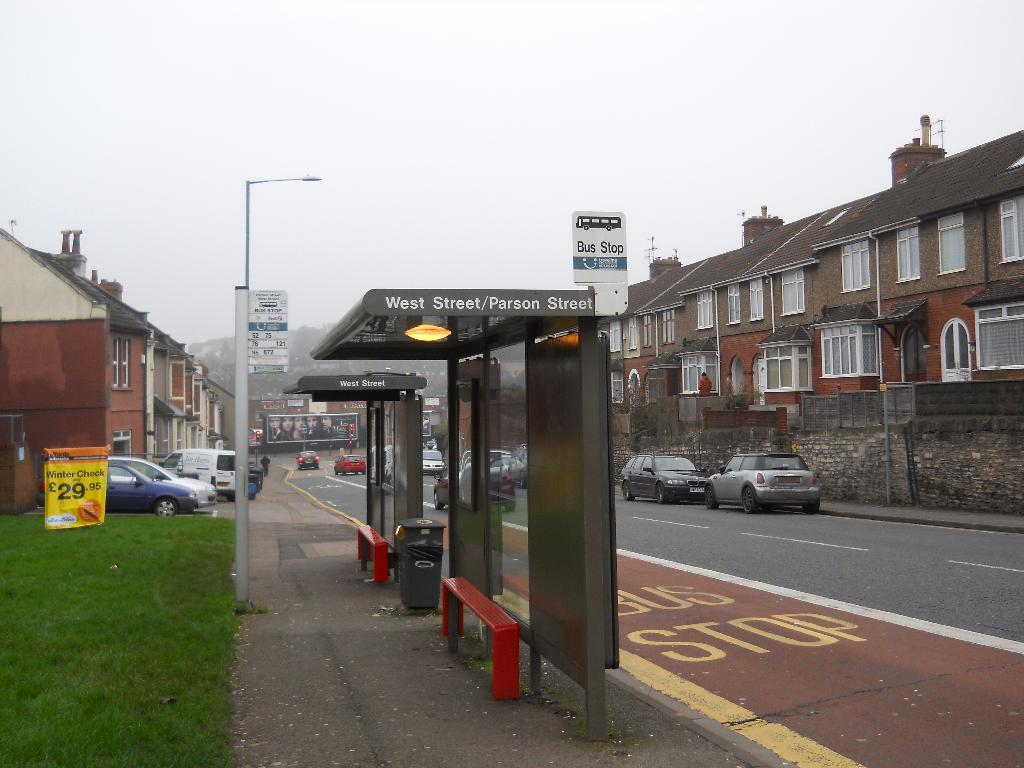Provide a one-sentence caption for the provided image. The bus stop for West Street/Parson Street sits to the left of the city street. 